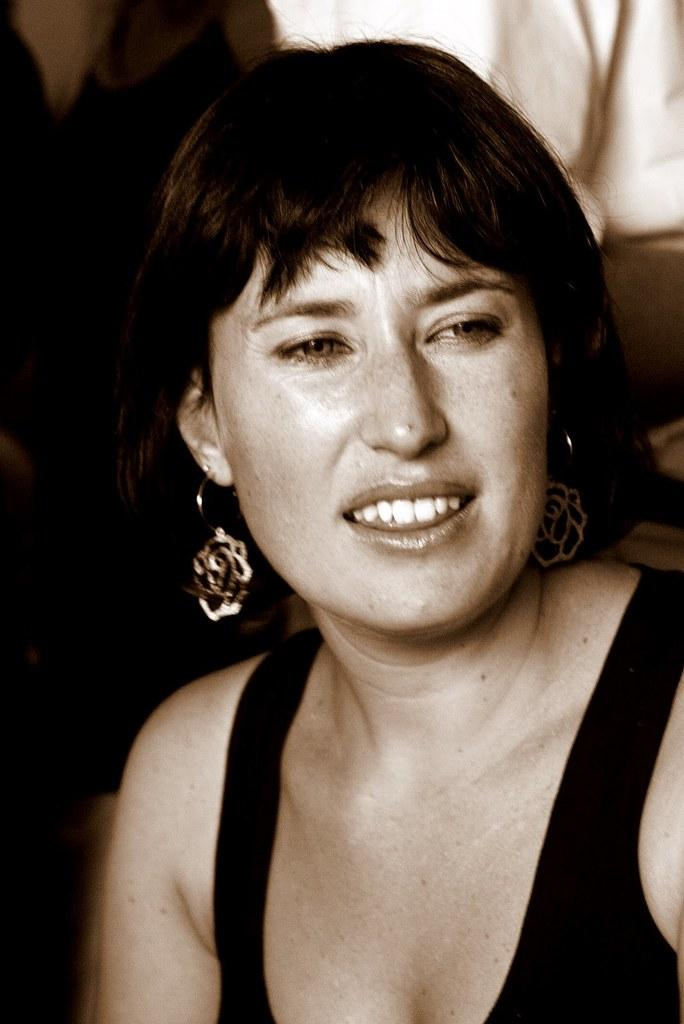Who is present in the image? There is a woman in the image. What is the woman wearing? The woman is wearing black clothing. Can you describe any accessories the woman is wearing? The woman is wearing earrings. What type of balloon can be seen in the image? There is no balloon present in the image. How does the earthquake affect the woman in the image? There is no earthquake depicted in the image, so its effect on the woman cannot be determined. 